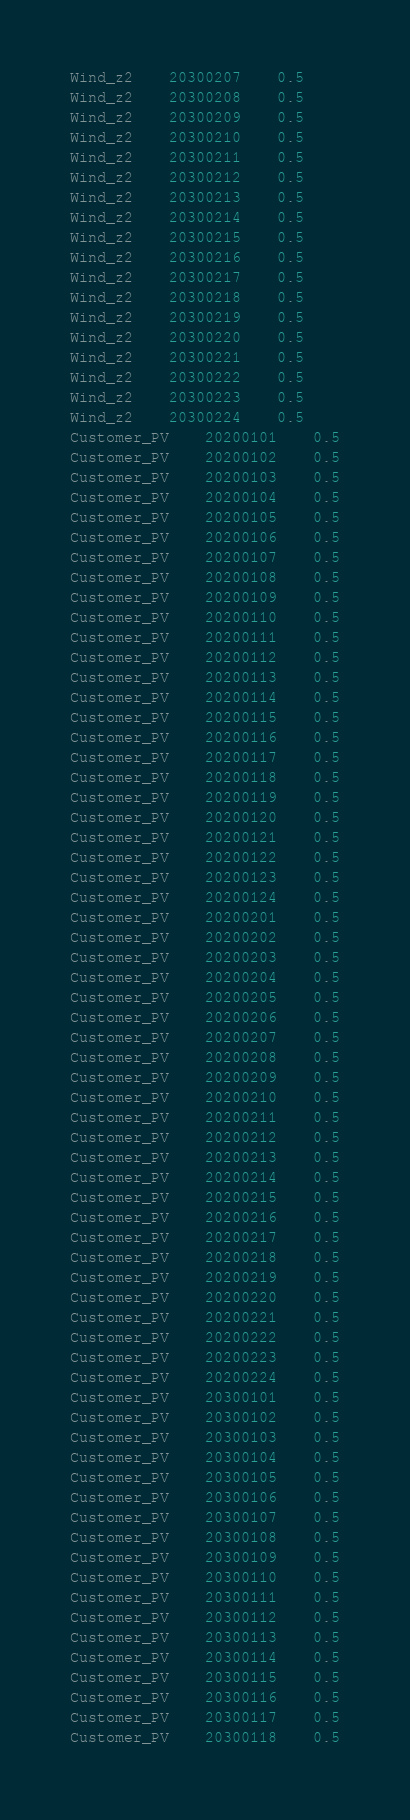<code> <loc_0><loc_0><loc_500><loc_500><_SQL_>Wind_z2	20300207	0.5
Wind_z2	20300208	0.5
Wind_z2	20300209	0.5
Wind_z2	20300210	0.5
Wind_z2	20300211	0.5
Wind_z2	20300212	0.5
Wind_z2	20300213	0.5
Wind_z2	20300214	0.5
Wind_z2	20300215	0.5
Wind_z2	20300216	0.5
Wind_z2	20300217	0.5
Wind_z2	20300218	0.5
Wind_z2	20300219	0.5
Wind_z2	20300220	0.5
Wind_z2	20300221	0.5
Wind_z2	20300222	0.5
Wind_z2	20300223	0.5
Wind_z2	20300224	0.5
Customer_PV	20200101	0.5
Customer_PV	20200102	0.5
Customer_PV	20200103	0.5
Customer_PV	20200104	0.5
Customer_PV	20200105	0.5
Customer_PV	20200106	0.5
Customer_PV	20200107	0.5
Customer_PV	20200108	0.5
Customer_PV	20200109	0.5
Customer_PV	20200110	0.5
Customer_PV	20200111	0.5
Customer_PV	20200112	0.5
Customer_PV	20200113	0.5
Customer_PV	20200114	0.5
Customer_PV	20200115	0.5
Customer_PV	20200116	0.5
Customer_PV	20200117	0.5
Customer_PV	20200118	0.5
Customer_PV	20200119	0.5
Customer_PV	20200120	0.5
Customer_PV	20200121	0.5
Customer_PV	20200122	0.5
Customer_PV	20200123	0.5
Customer_PV	20200124	0.5
Customer_PV	20200201	0.5
Customer_PV	20200202	0.5
Customer_PV	20200203	0.5
Customer_PV	20200204	0.5
Customer_PV	20200205	0.5
Customer_PV	20200206	0.5
Customer_PV	20200207	0.5
Customer_PV	20200208	0.5
Customer_PV	20200209	0.5
Customer_PV	20200210	0.5
Customer_PV	20200211	0.5
Customer_PV	20200212	0.5
Customer_PV	20200213	0.5
Customer_PV	20200214	0.5
Customer_PV	20200215	0.5
Customer_PV	20200216	0.5
Customer_PV	20200217	0.5
Customer_PV	20200218	0.5
Customer_PV	20200219	0.5
Customer_PV	20200220	0.5
Customer_PV	20200221	0.5
Customer_PV	20200222	0.5
Customer_PV	20200223	0.5
Customer_PV	20200224	0.5
Customer_PV	20300101	0.5
Customer_PV	20300102	0.5
Customer_PV	20300103	0.5
Customer_PV	20300104	0.5
Customer_PV	20300105	0.5
Customer_PV	20300106	0.5
Customer_PV	20300107	0.5
Customer_PV	20300108	0.5
Customer_PV	20300109	0.5
Customer_PV	20300110	0.5
Customer_PV	20300111	0.5
Customer_PV	20300112	0.5
Customer_PV	20300113	0.5
Customer_PV	20300114	0.5
Customer_PV	20300115	0.5
Customer_PV	20300116	0.5
Customer_PV	20300117	0.5
Customer_PV	20300118	0.5</code> 